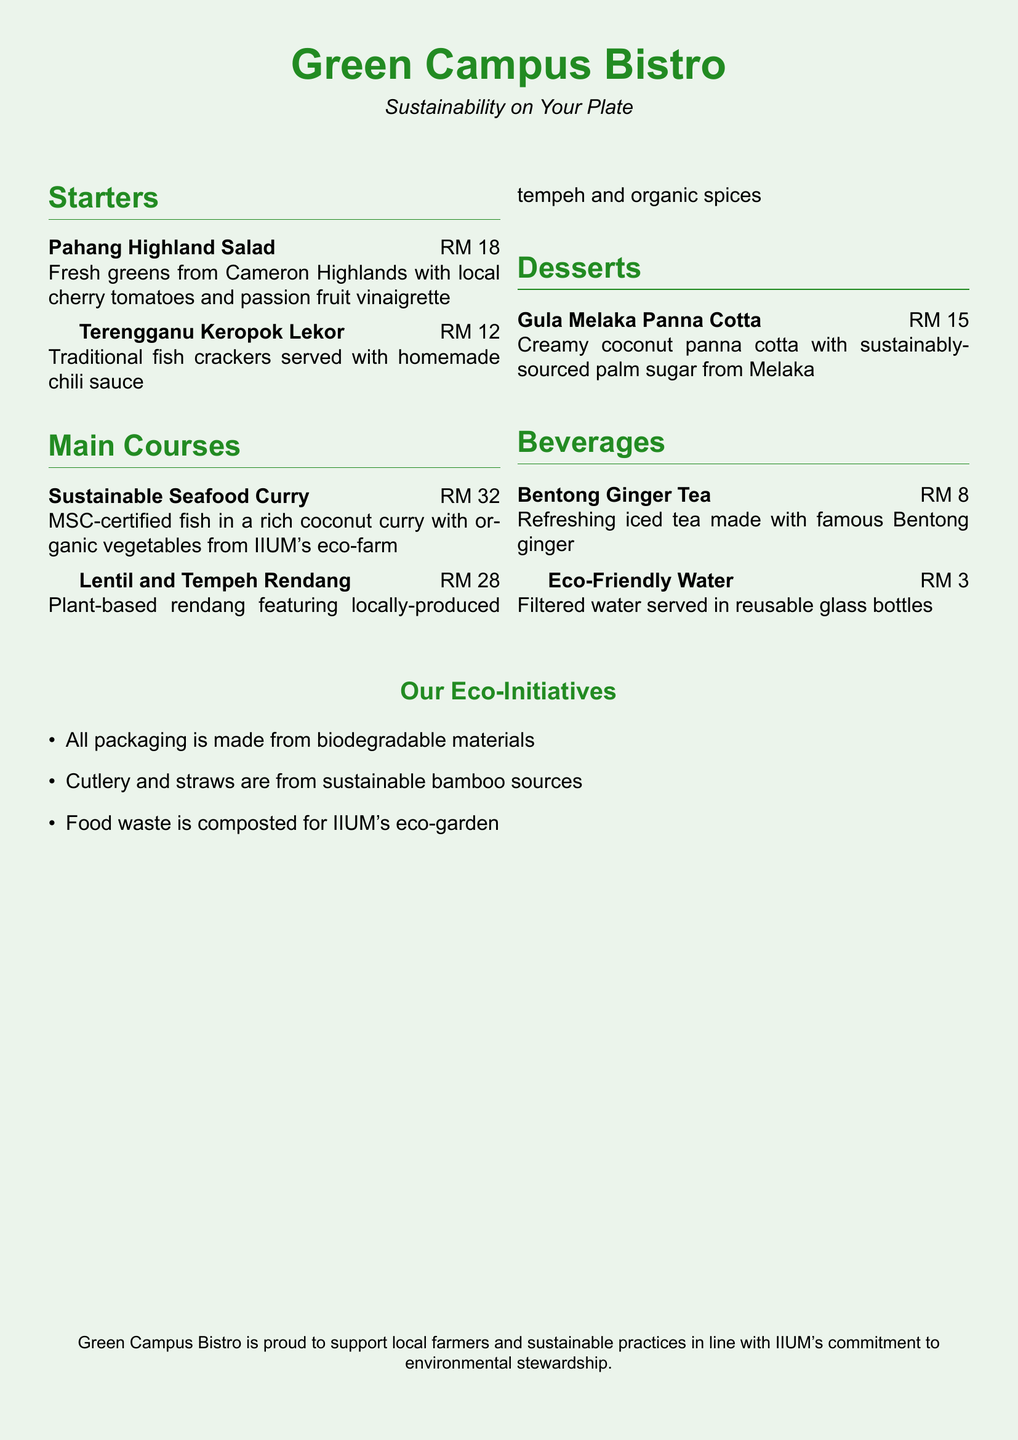What is the name of the bistro? The name of the bistro is prominently featured at the top of the document.
Answer: Green Campus Bistro What is the price of the Pahang Highland Salad? The price is next to the dish name in the Starters section.
Answer: RM 18 What type of tea is offered? The Beverages section lists different drinks, including a specific tea.
Answer: Bentong Ginger Tea Which seafood is certified sustainable? The Main Courses section indicates the sustainability of the seafood used.
Answer: MSC-certified fish What is made from biodegradable materials? The list of eco-initiatives outlines what is environmentally friendly.
Answer: All packaging What is used for the dessert Gula Melaka Panna Cotta? The ingredients for the dessert are included in the description.
Answer: Sustainably-sourced palm sugar How much does Eco-Friendly Water cost? The price for the beverage is found next to its name in the Beverages section.
Answer: RM 3 What is the primary goal of the Green Campus Bistro? The document mentions the bistro's commitment at the end.
Answer: Support local farmers and sustainable practices 